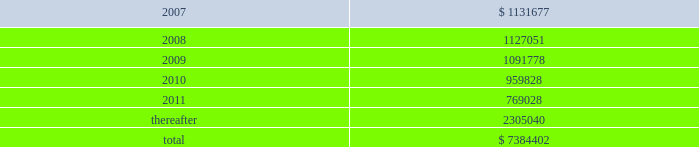American tower corporation and subsidiaries notes to consolidated financial statements 2014 ( continued ) future minimum rental receipts expected from customers under non-cancelable operating lease agreements in effect at december 31 , 2006 are as follows ( in thousands ) : year ending december 31 .
Legal and governmental proceedings related to review of stock option granting practices and related accounting 2014on may 18 , 2006 , the company received a letter of informal inquiry from the sec division of enforcement requesting documents related to company stock option grants and stock option practices .
The inquiry is focused on stock options granted to senior management and members of the company 2019s board of directors during the period 1997 to the present .
The company continues to cooperate with the sec to provide the requested information and documents .
On may 19 , 2006 , the company received a subpoena from the united states attorney 2019s office for the eastern district of new york for records and information relating to its stock option granting practices .
The subpoena requests materials related to certain stock options granted between 1995 and the present .
The company continues to cooperate with the u.s .
Attorney 2019s office to provide the requested information and documents .
On may 26 , 2006 , a securities class action was filed in united states district court for the district of massachusetts against the company and certain of its current officers by john s .
Greenebaum for monetary relief .
Specifically , the complaint names the company , james d .
Taiclet , jr .
And bradley e .
Singer as defendants and alleges that the defendants violated federal securities laws in connection with public statements made relating to the company 2019s stock option practices and related accounting .
The complaint asserts claims under sections 10 ( b ) and 20 ( a ) of the securities exchange act of 1934 , as amended ( exchange act ) and sec rule 10b-5 .
In december 2006 , the court appointed the steamship trade association-international longshoreman 2019s association pension fund as the lead plaintiff .
On may 24 , 2006 and june 14 , 2006 , two shareholder derivative lawsuits were filed in suffolk county superior court in massachusetts by eric johnston and robert l .
Garber , respectively .
The lawsuits were filed against certain of the company 2019s current and former officers and directors for alleged breaches of fiduciary duties and unjust enrichment in connection with the company 2019s stock option granting practices .
The lawsuits also name the company as a nominal defendant .
The lawsuits seek to recover the damages sustained by the company and disgorgement of all profits received with respect to the alleged backdated stock options .
In october 2006 , these two lawsuits were consolidated and transferred to the court 2019s business litigation session .
On june 13 , 2006 , june 22 , 2006 and august 23 , 2006 , three shareholder derivative lawsuits were filed in united states district court for the district of massachusetts by new south wales treasury corporation , as trustee for the alpha international managers trust , frank c .
Kalil and don holland , and leslie cramer , respectively .
The lawsuits were filed against certain of the company 2019s current and former officers and directors for alleged breaches of fiduciary duties , waste of corporate assets , gross mismanagement and unjust enrichment in connection with the company 2019s stock option granting practices .
The lawsuits also name the company as a nominal defendant .
In december 2006 , the court consolidated these three lawsuits and appointed new south wales treasury corporation as the lead plaintiff .
On february 9 , 2007 , the plaintiffs filed a consolidated .
What portion of the total future minimum rental receipts is expected to be collected in the next 24 months? 
Computations: ((1131677 / 1127051) / 7384402)
Answer: 0.0. 